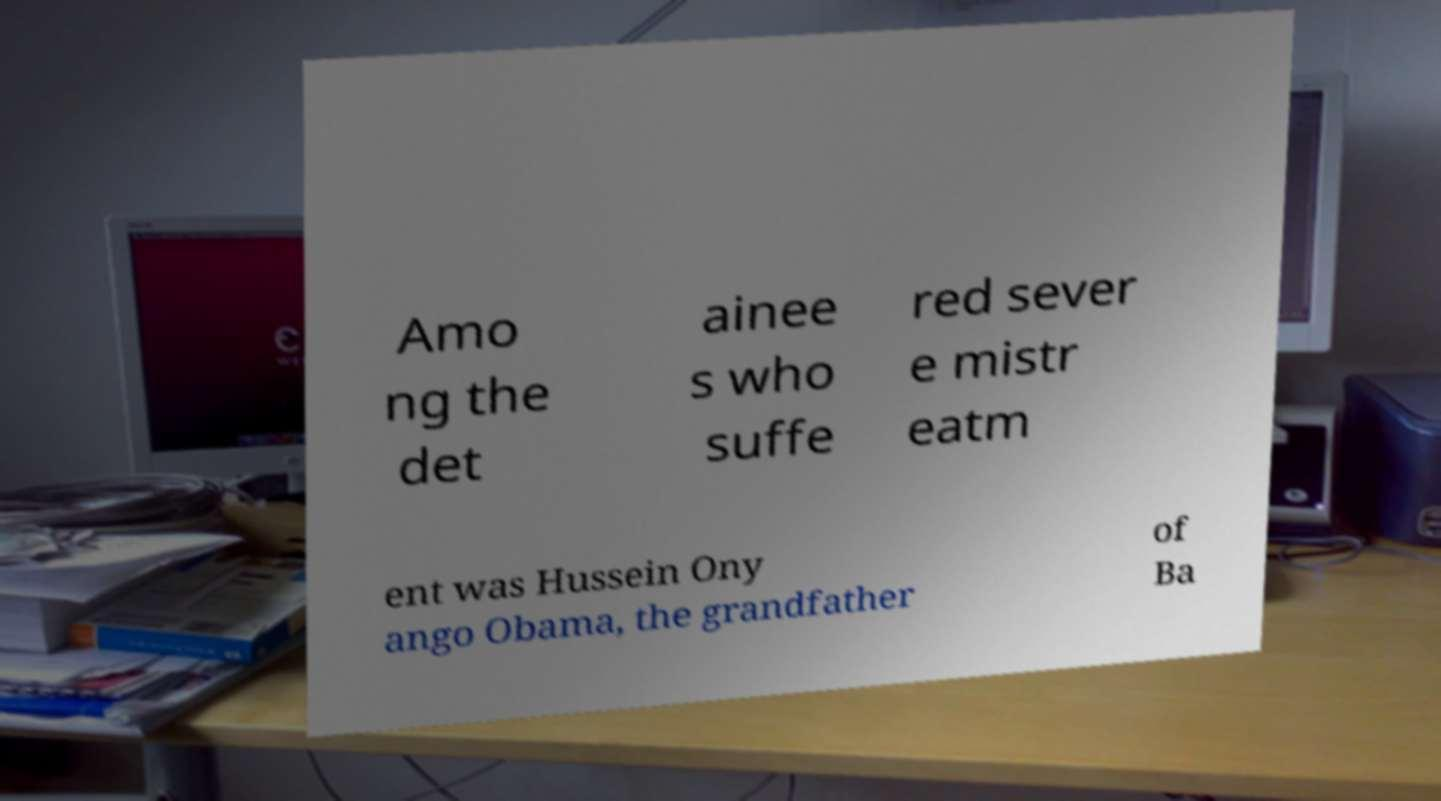Please identify and transcribe the text found in this image. Amo ng the det ainee s who suffe red sever e mistr eatm ent was Hussein Ony ango Obama, the grandfather of Ba 